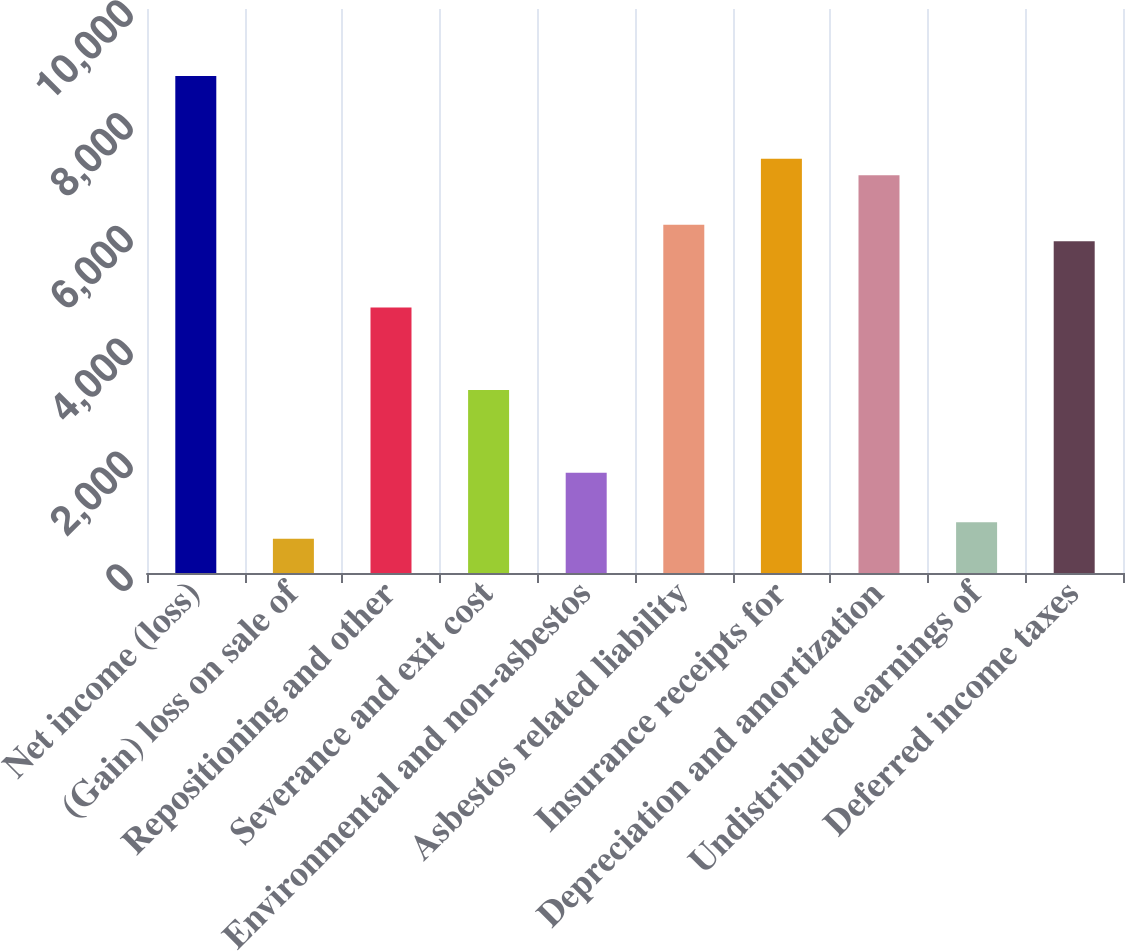Convert chart to OTSL. <chart><loc_0><loc_0><loc_500><loc_500><bar_chart><fcel>Net income (loss)<fcel>(Gain) loss on sale of<fcel>Repositioning and other<fcel>Severance and exit cost<fcel>Environmental and non-asbestos<fcel>Asbestos related liability<fcel>Insurance receipts for<fcel>Depreciation and amortization<fcel>Undistributed earnings of<fcel>Deferred income taxes<nl><fcel>8810<fcel>606<fcel>4708<fcel>3243<fcel>1778<fcel>6173<fcel>7345<fcel>7052<fcel>899<fcel>5880<nl></chart> 